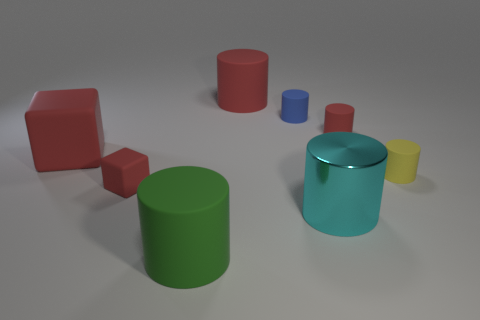Is the number of cyan cylinders on the right side of the green cylinder greater than the number of red blocks in front of the small block?
Ensure brevity in your answer.  Yes. The large matte thing that is in front of the small rubber object right of the red thing that is on the right side of the cyan metal cylinder is what color?
Provide a succinct answer. Green. There is a big rubber thing in front of the small red matte cube; does it have the same color as the metallic cylinder?
Your answer should be very brief. No. What number of other objects are there of the same color as the big rubber cube?
Make the answer very short. 3. What number of objects are either yellow matte objects or red cubes?
Your answer should be very brief. 3. How many things are large red matte cylinders or tiny red matte objects to the right of the large cyan metal thing?
Ensure brevity in your answer.  2. Does the tiny yellow cylinder have the same material as the blue thing?
Your answer should be compact. Yes. How many other things are the same material as the big block?
Offer a very short reply. 6. Are there more big green shiny spheres than shiny things?
Provide a succinct answer. No. Does the red matte object on the right side of the large red matte cylinder have the same shape as the cyan shiny thing?
Provide a succinct answer. Yes. 